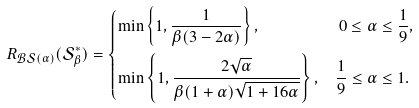<formula> <loc_0><loc_0><loc_500><loc_500>R _ { \mathcal { B S } ( \alpha ) } ( \mathcal { S } ^ { * } _ { \beta } ) & = \begin{dcases} \min \left \{ 1 , \frac { 1 } { \beta ( 3 - 2 \alpha ) } \right \} , & \ 0 \leq \alpha \leq \frac { 1 } { 9 } , \\ \min \left \{ 1 , \frac { 2 \sqrt { \alpha } } { \beta ( 1 + \alpha ) \sqrt { 1 + 1 6 \alpha } } \right \} , & \frac { 1 } { 9 } \leq \alpha \leq 1 . \end{dcases}</formula> 